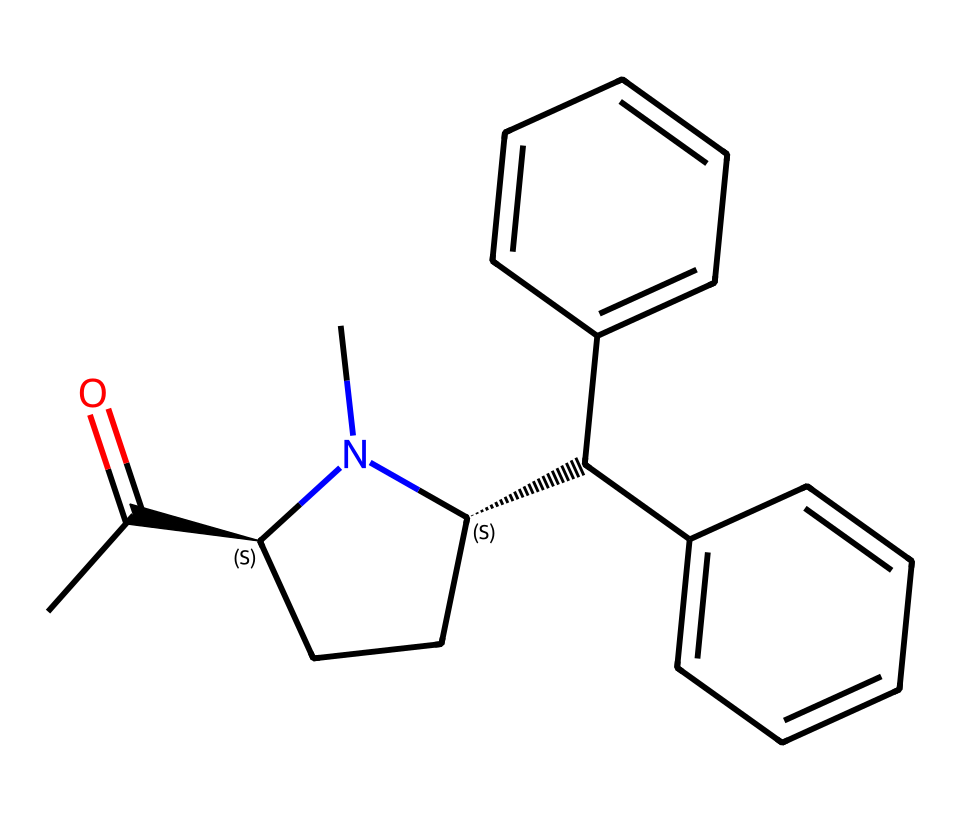What is the molecular formula of methylphenidate? To determine the molecular formula, I need to count the number of each type of atom based on the SMILES. The structure contains one nitrogen (N), two carbons from the side chain (C(C)=O), two aromatic rings (each contributing six carbons), and additional carbon atoms in the ring structure. Adding these up gives C14H19N.
Answer: C14H19N How many chiral centers are present in methylphenidate's structure? Chiral centers are typically identified by looking for carbon atoms that are attached to four different groups. In the provided SMILES, there are two stereocenters indicated by the symbols [C@H] (which represent the chiral carbons). Therefore, the total is two.
Answer: 2 What type of organic compound is methylphenidate categorized as? Methylphenidate is commonly classified based on its structure and functionality. Given it has an amine (due to nitrogen) and is used therapeutically for ADHD, it falls under the category of a stimulant medication.
Answer: stimulant Which functional groups are present in methylphenidate? By examining the SMILES structure, I can identify several functional groups. The presence of the nitrogen indicates that it contains an amine group. Additionally, the C(C)=O suggests a carbonyl (ketone) functionality. Therefore, the primary functional groups are an amine and a carbonyl.
Answer: amine, carbonyl What is the total number of carbon atoms in methylphenidate? To find the number of carbon atoms, I consider each part of the SMILES representation. The side chain (C(C)=O) contributes 2 carbons, the two benzene rings provide 12 carbons (6 each), and the cyclic structure includes 3 additional carbons. Adding these gives a total of 14 carbons.
Answer: 14 